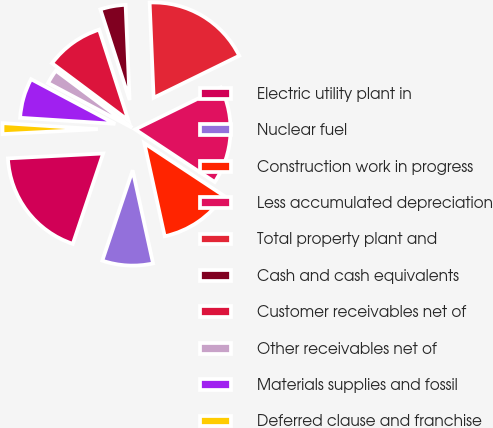<chart> <loc_0><loc_0><loc_500><loc_500><pie_chart><fcel>Electric utility plant in<fcel>Nuclear fuel<fcel>Construction work in progress<fcel>Less accumulated depreciation<fcel>Total property plant and<fcel>Cash and cash equivalents<fcel>Customer receivables net of<fcel>Other receivables net of<fcel>Materials supplies and fossil<fcel>Deferred clause and franchise<nl><fcel>19.02%<fcel>8.59%<fcel>12.27%<fcel>16.56%<fcel>18.4%<fcel>4.29%<fcel>9.82%<fcel>2.45%<fcel>6.75%<fcel>1.84%<nl></chart> 